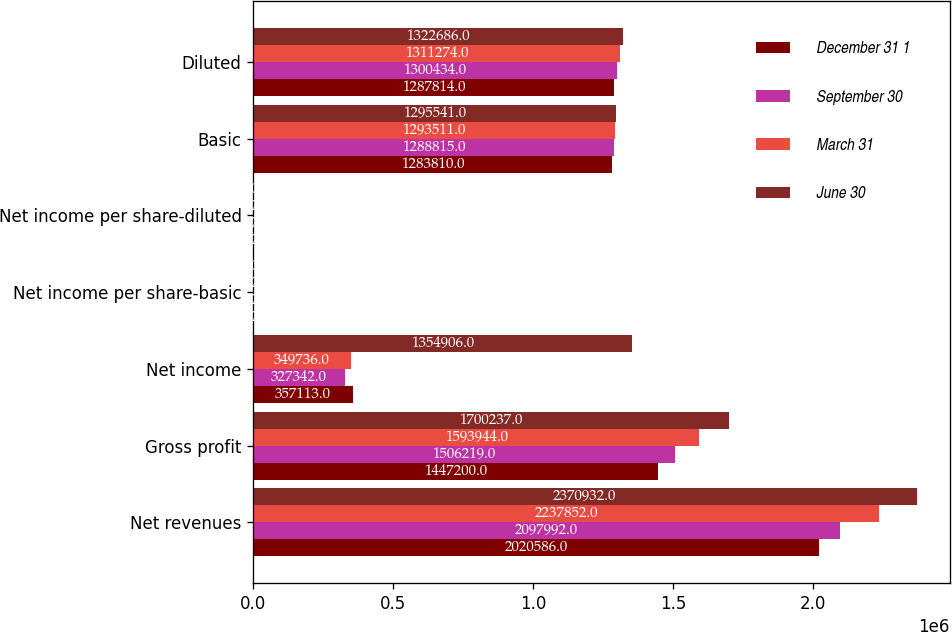<chart> <loc_0><loc_0><loc_500><loc_500><stacked_bar_chart><ecel><fcel>Net revenues<fcel>Gross profit<fcel>Net income<fcel>Net income per share-basic<fcel>Net income per share-diluted<fcel>Basic<fcel>Diluted<nl><fcel>December 31 1<fcel>2.02059e+06<fcel>1.4472e+06<fcel>357113<fcel>0.28<fcel>0.28<fcel>1.28381e+06<fcel>1.28781e+06<nl><fcel>September 30<fcel>2.09799e+06<fcel>1.50622e+06<fcel>327342<fcel>0.25<fcel>0.25<fcel>1.28882e+06<fcel>1.30043e+06<nl><fcel>March 31<fcel>2.23785e+06<fcel>1.59394e+06<fcel>349736<fcel>0.27<fcel>0.27<fcel>1.29351e+06<fcel>1.31127e+06<nl><fcel>June 30<fcel>2.37093e+06<fcel>1.70024e+06<fcel>1.35491e+06<fcel>1.05<fcel>1.02<fcel>1.29554e+06<fcel>1.32269e+06<nl></chart> 